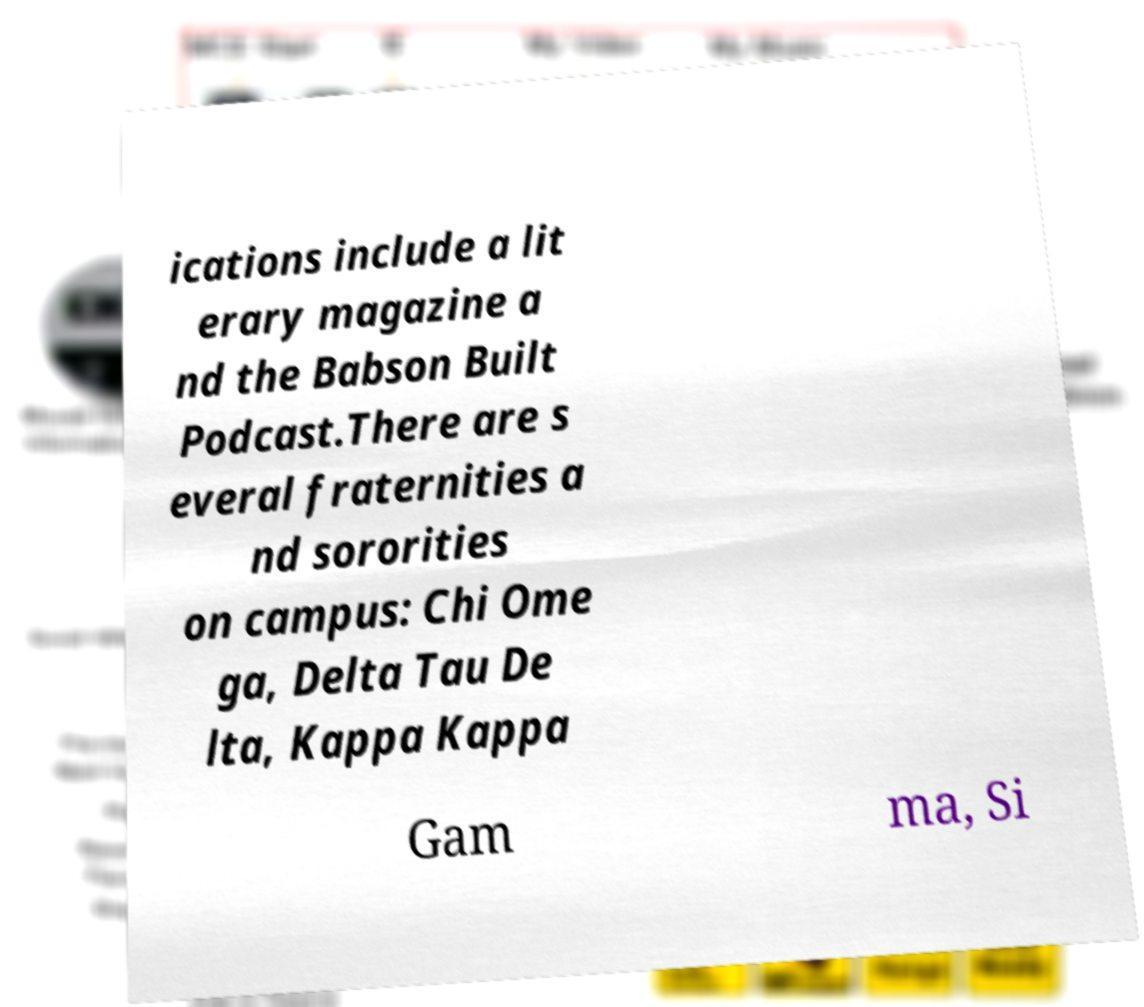Can you accurately transcribe the text from the provided image for me? ications include a lit erary magazine a nd the Babson Built Podcast.There are s everal fraternities a nd sororities on campus: Chi Ome ga, Delta Tau De lta, Kappa Kappa Gam ma, Si 